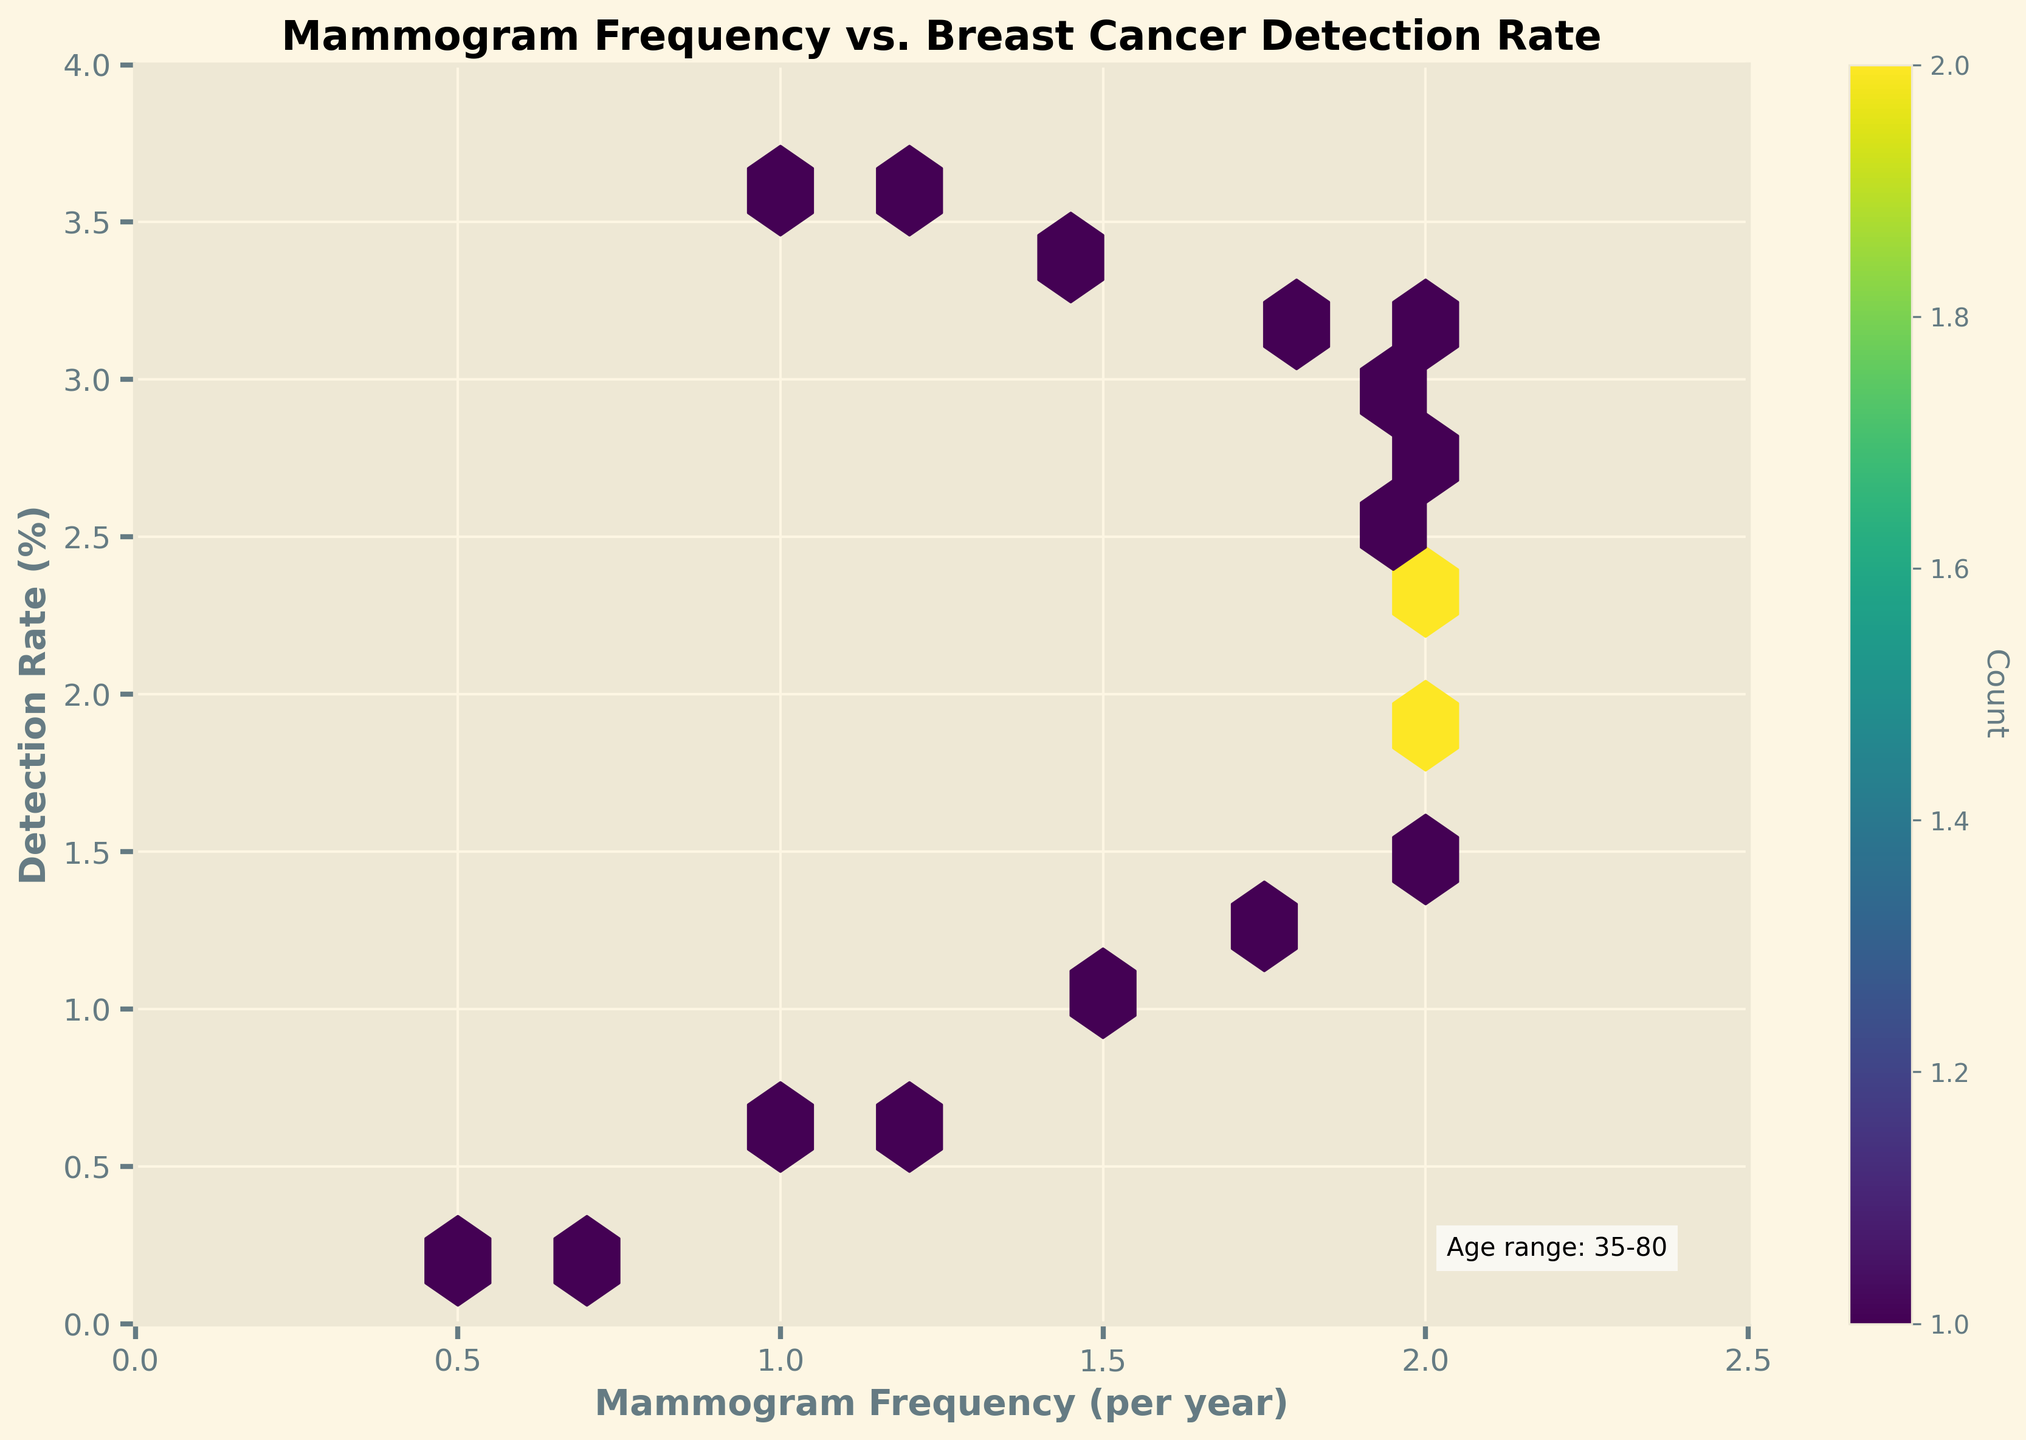How many points are included in the hexbin plot? The plot includes mammogram frequency and detection rates for ages 35 to 80. Each age point corresponds to one plot point. By examining the data, there are 18 points in the figure.
Answer: 18 Which mammogram frequency shows the highest concentration of data points? By looking at the density of hexagon colors, the highest concentration of data points appears around the mammogram frequency of 2.0 per year.
Answer: 2.0 per year What does the color intensity in the hexbin plot represent? The color in the hexbin plot represents the count of data points within each hexagon. Darker colors indicate a higher number of overlapping data points.
Answer: Count of data points What is the general trend between mammogram frequency and detection rate as age increases? The plot shows that as the age increases, the mammogram frequency generally reaches a peak around 2.0 per year, while the detection rate increases consistently.
Answer: Detection rate increases with age At what age range does the plot note that the mammogram frequency remained constant? By observing the x-axis and corresponding data points, it's noted that mammogram frequency remains constant at 2.0 per year from age 50 onwards to about age 70.
Answer: Age 50 to 70 Is there any instance of high detection rate despite relatively lower mammogram frequency? Yes, the plot shows data points after age 70 where detection rates continue high (up to 3.6%) despite the decreasing mammogram frequency (1.0 - 1.8 per year).
Answer: After age 70 How does the detection rate for age 40 compare to that at age 80 in terms of their respective mammogram frequencies? At age 40, the detection rate is 0.5% with a frequency of 1.0 per year, whereas at age 80, the detection rate is 3.6% with a frequency reduced to 1.0 per year.
Answer: Age 80 detection rate is higher despite same frequency What range of mammogram frequency seems most common for detection rates between 1% and 2%? The plot's hexbin color intensity in the range of 1% to 2% detection rates shows maximum frequency clusters around 2.0 per year.
Answer: Around 2.0 per year What is the title of the hexbin plot? The title of the plot can be observed at the top center of the figure and it reads, "Mammogram Frequency vs. Breast Cancer Detection Rate."
Answer: Mammogram Frequency vs. Breast Cancer Detection Rate What color is used in the hexbin plot to indicate areas with a high count of data points? The plot uses a color intensity scheme (viridis) where darker hues indicate higher counts of overlapping data points in specific hexagons.
Answer: Darker hues 